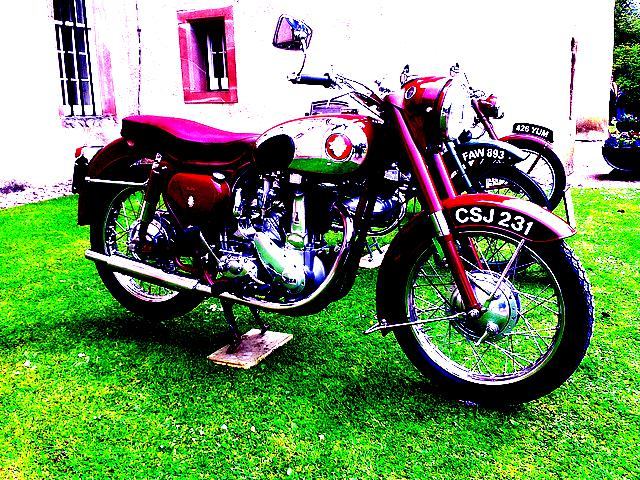What could be the significance of the registration plates on the motorcycle? Vintage registration plates like the ones shown can provide information about the motorcycle's history and origin. Collectors often value such details as they can trace the vehicle's authenticity and any historical significance it may carry. 